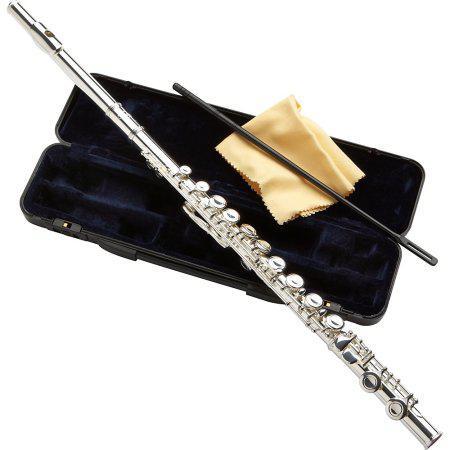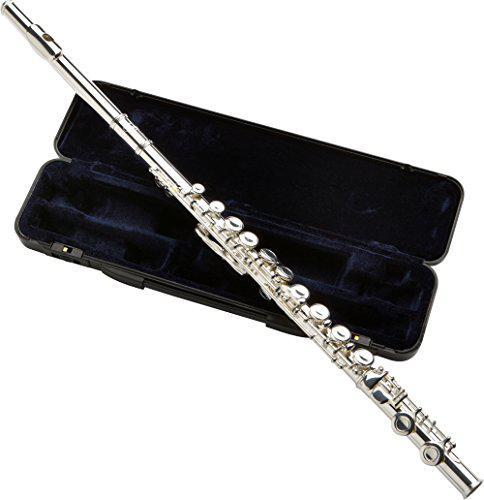The first image is the image on the left, the second image is the image on the right. Examine the images to the left and right. Is the description "One of the instrument cases is completely closed." accurate? Answer yes or no. No. The first image is the image on the left, the second image is the image on the right. For the images displayed, is the sentence "In the image pair there are two flutes propped over their carrying cases" factually correct? Answer yes or no. Yes. 